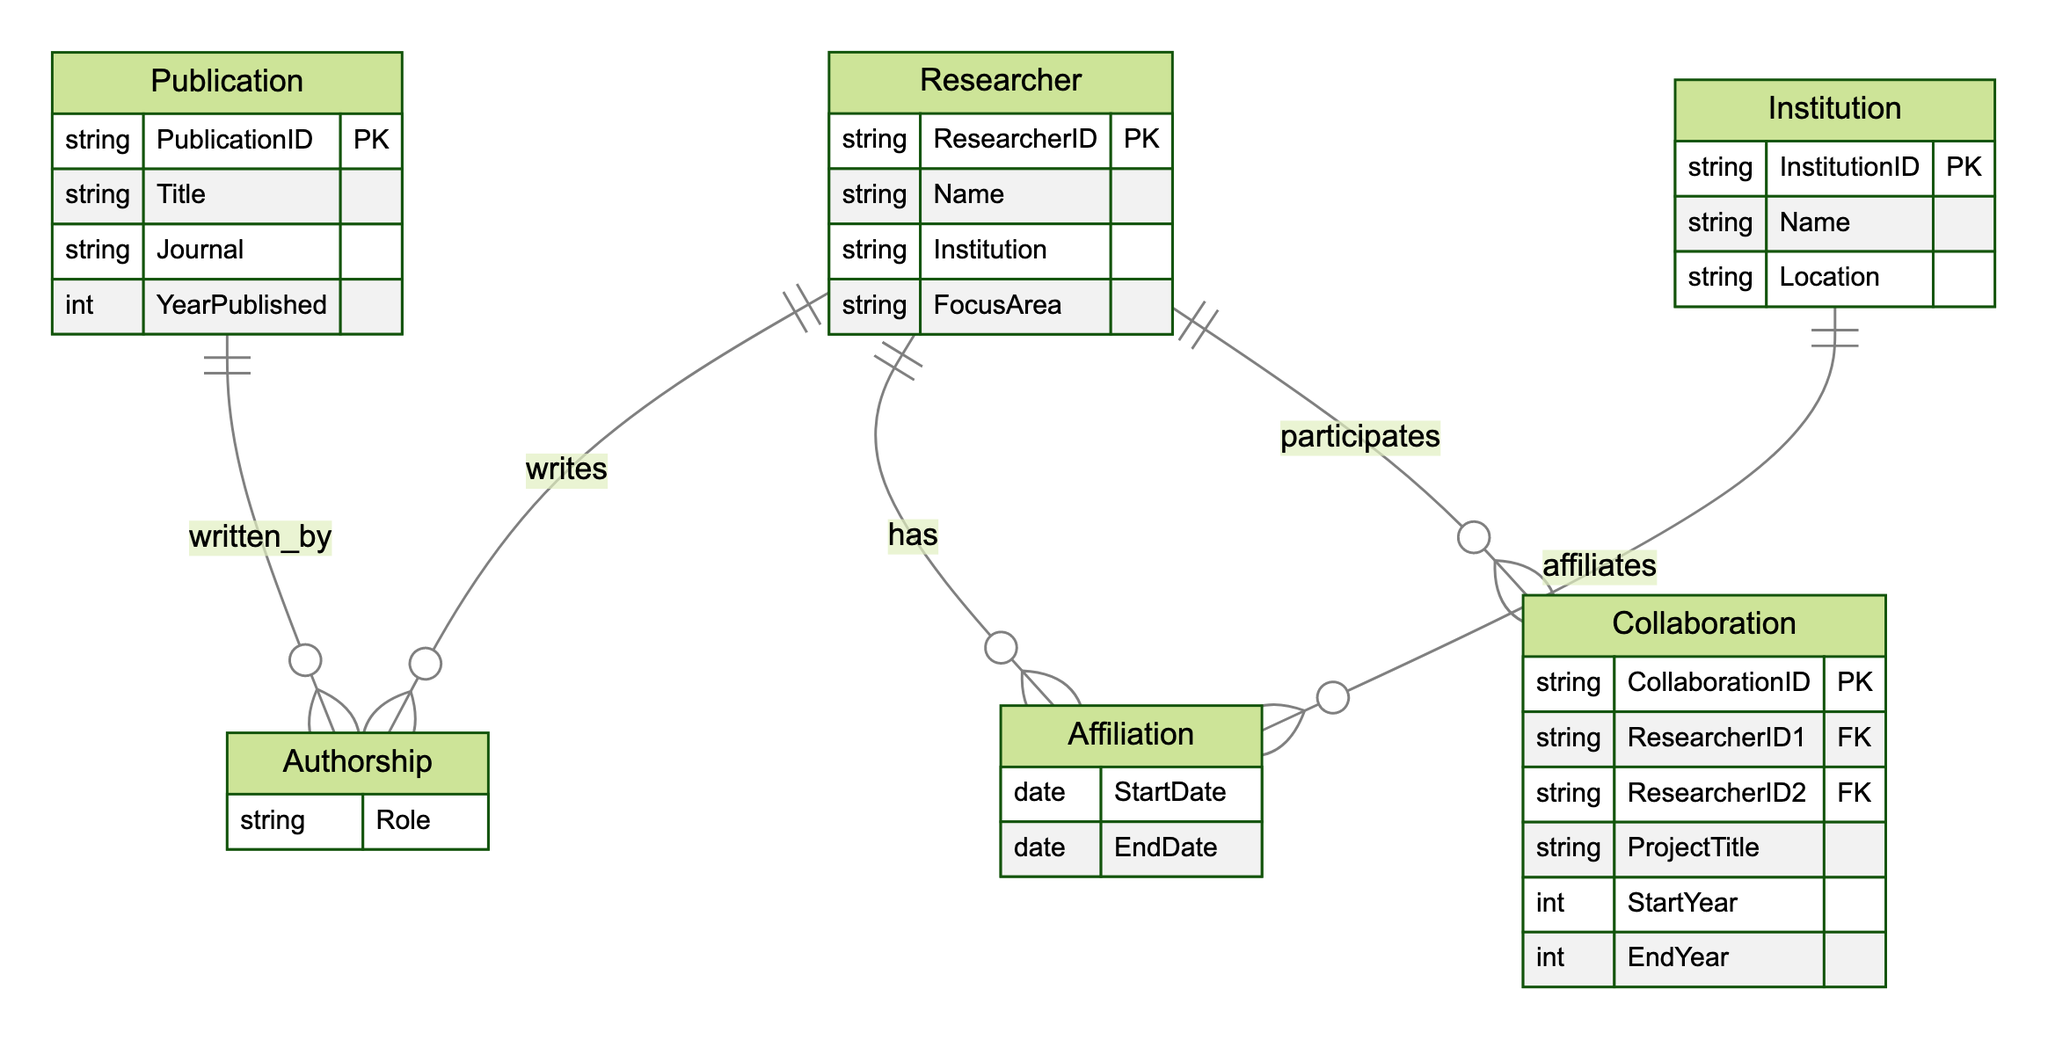What entities are included in the diagram? The diagram includes four entities: Researcher, Institution, Publication, and Collaboration. Each entity is represented with its attributes and defines the overall structure of the research collaboration network.
Answer: Researcher, Institution, Publication, Collaboration How many primary keys are present in the diagram? The diagram lists four entities, each with a primary key: ResearcherID, InstitutionID, PublicationID, and CollaborationID. Thus, there are four primary keys in total.
Answer: Four What type of relationship connects a Researcher to a Publication? A Researcher is connected to a Publication through the Authorship relationship, which indicates that a Researcher writes or contributes to a Publication. This relationship is distinguished in the diagram by its associated attributes.
Answer: Authorship Which entity represents the location of the researchers' affiliations? The Institution entity represents the location of the affiliations for Researchers. It contains the Location attribute, which provides necessary geographical information.
Answer: Institution How many relationships connect the Researcher entity to other entities? The Researcher entity connects to three different relationships: Authorship, Affiliation, and Collaboration. This means a total of three relationships link Researchers to other entities in the diagram.
Answer: Three If a Researcher has an Affiliation, what attributes are given in that relationship? The Affiliation relationship has two attributes: StartDate and EndDate, which specify the duration of the Researcher's affiliation with an Institution. This highlights the time aspect of the affiliation.
Answer: StartDate, EndDate What is the role of a Researcher in the Authorship relationship? The role of a Researcher in the Authorship relationship is defined by the Role attribute, indicating the specific contribution or position the Researcher holds within the context of the Publication.
Answer: Role How does the Collaboration relationship connect two Researchers? The Collaboration relationship connects two Researchers by referencing ResearcherID1 and ResearcherID2 as foreign keys, indicating the participants in a research project along with other project-specific details.
Answer: ResearcherID1, ResearcherID2 What attribute of the Publication entity indicates the year it was created? The YearPublished attribute of the Publication entity indicates the year the publication was created, providing a clear timeline for when the research output was documented.
Answer: YearPublished 